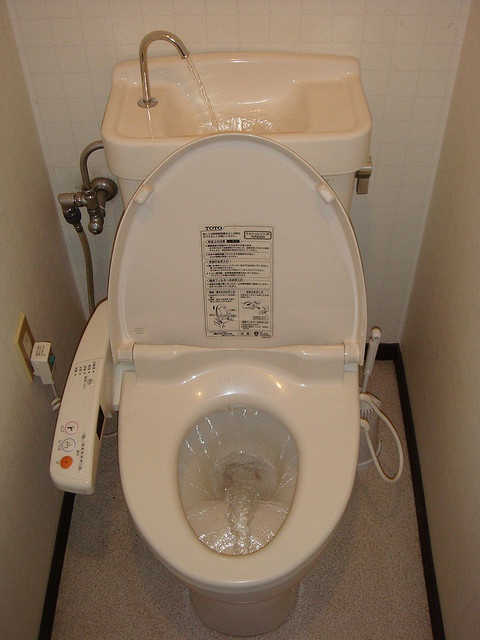Describe the objects in this image and their specific colors. I can see toilet in gray and tan tones and sink in gray and tan tones in this image. 